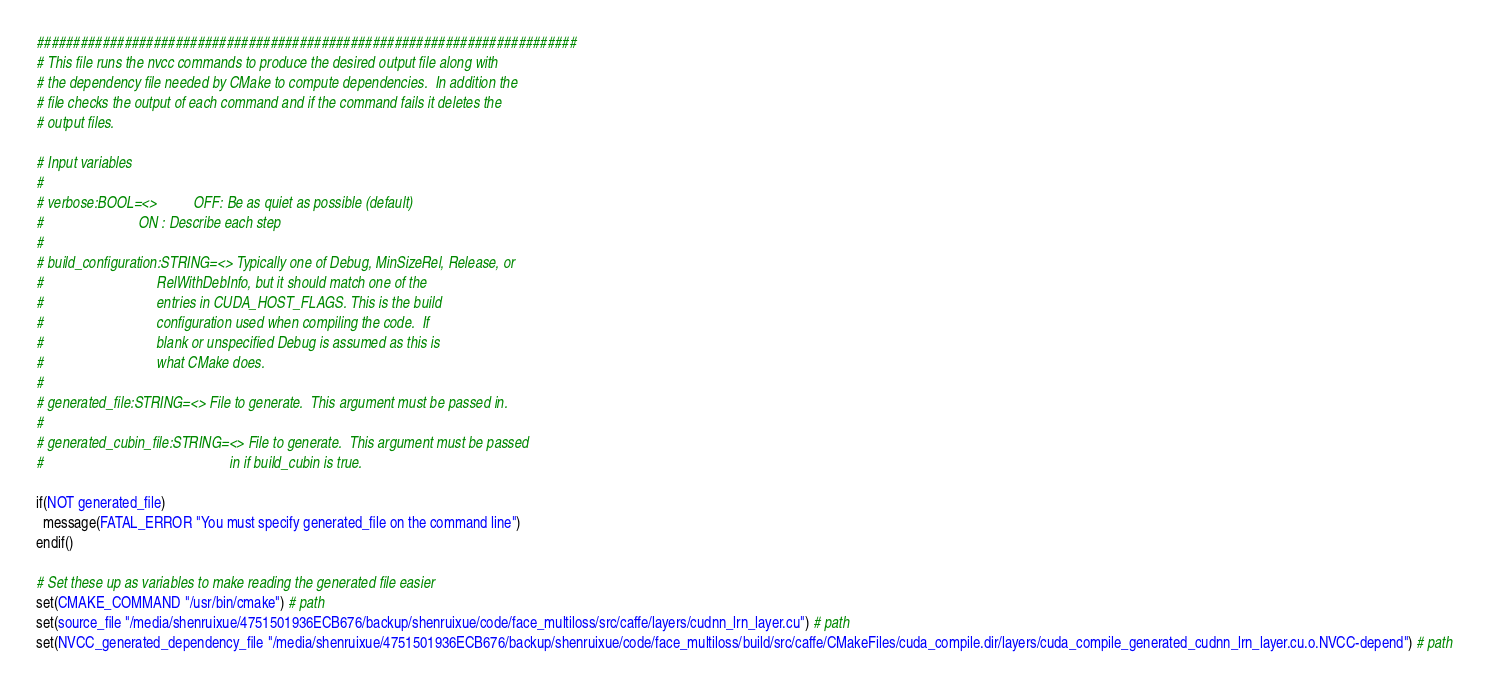<code> <loc_0><loc_0><loc_500><loc_500><_CMake_>##########################################################################
# This file runs the nvcc commands to produce the desired output file along with
# the dependency file needed by CMake to compute dependencies.  In addition the
# file checks the output of each command and if the command fails it deletes the
# output files.

# Input variables
#
# verbose:BOOL=<>          OFF: Be as quiet as possible (default)
#                          ON : Describe each step
#
# build_configuration:STRING=<> Typically one of Debug, MinSizeRel, Release, or
#                               RelWithDebInfo, but it should match one of the
#                               entries in CUDA_HOST_FLAGS. This is the build
#                               configuration used when compiling the code.  If
#                               blank or unspecified Debug is assumed as this is
#                               what CMake does.
#
# generated_file:STRING=<> File to generate.  This argument must be passed in.
#
# generated_cubin_file:STRING=<> File to generate.  This argument must be passed
#                                                   in if build_cubin is true.

if(NOT generated_file)
  message(FATAL_ERROR "You must specify generated_file on the command line")
endif()

# Set these up as variables to make reading the generated file easier
set(CMAKE_COMMAND "/usr/bin/cmake") # path
set(source_file "/media/shenruixue/4751501936ECB676/backup/shenruixue/code/face_multiloss/src/caffe/layers/cudnn_lrn_layer.cu") # path
set(NVCC_generated_dependency_file "/media/shenruixue/4751501936ECB676/backup/shenruixue/code/face_multiloss/build/src/caffe/CMakeFiles/cuda_compile.dir/layers/cuda_compile_generated_cudnn_lrn_layer.cu.o.NVCC-depend") # path</code> 